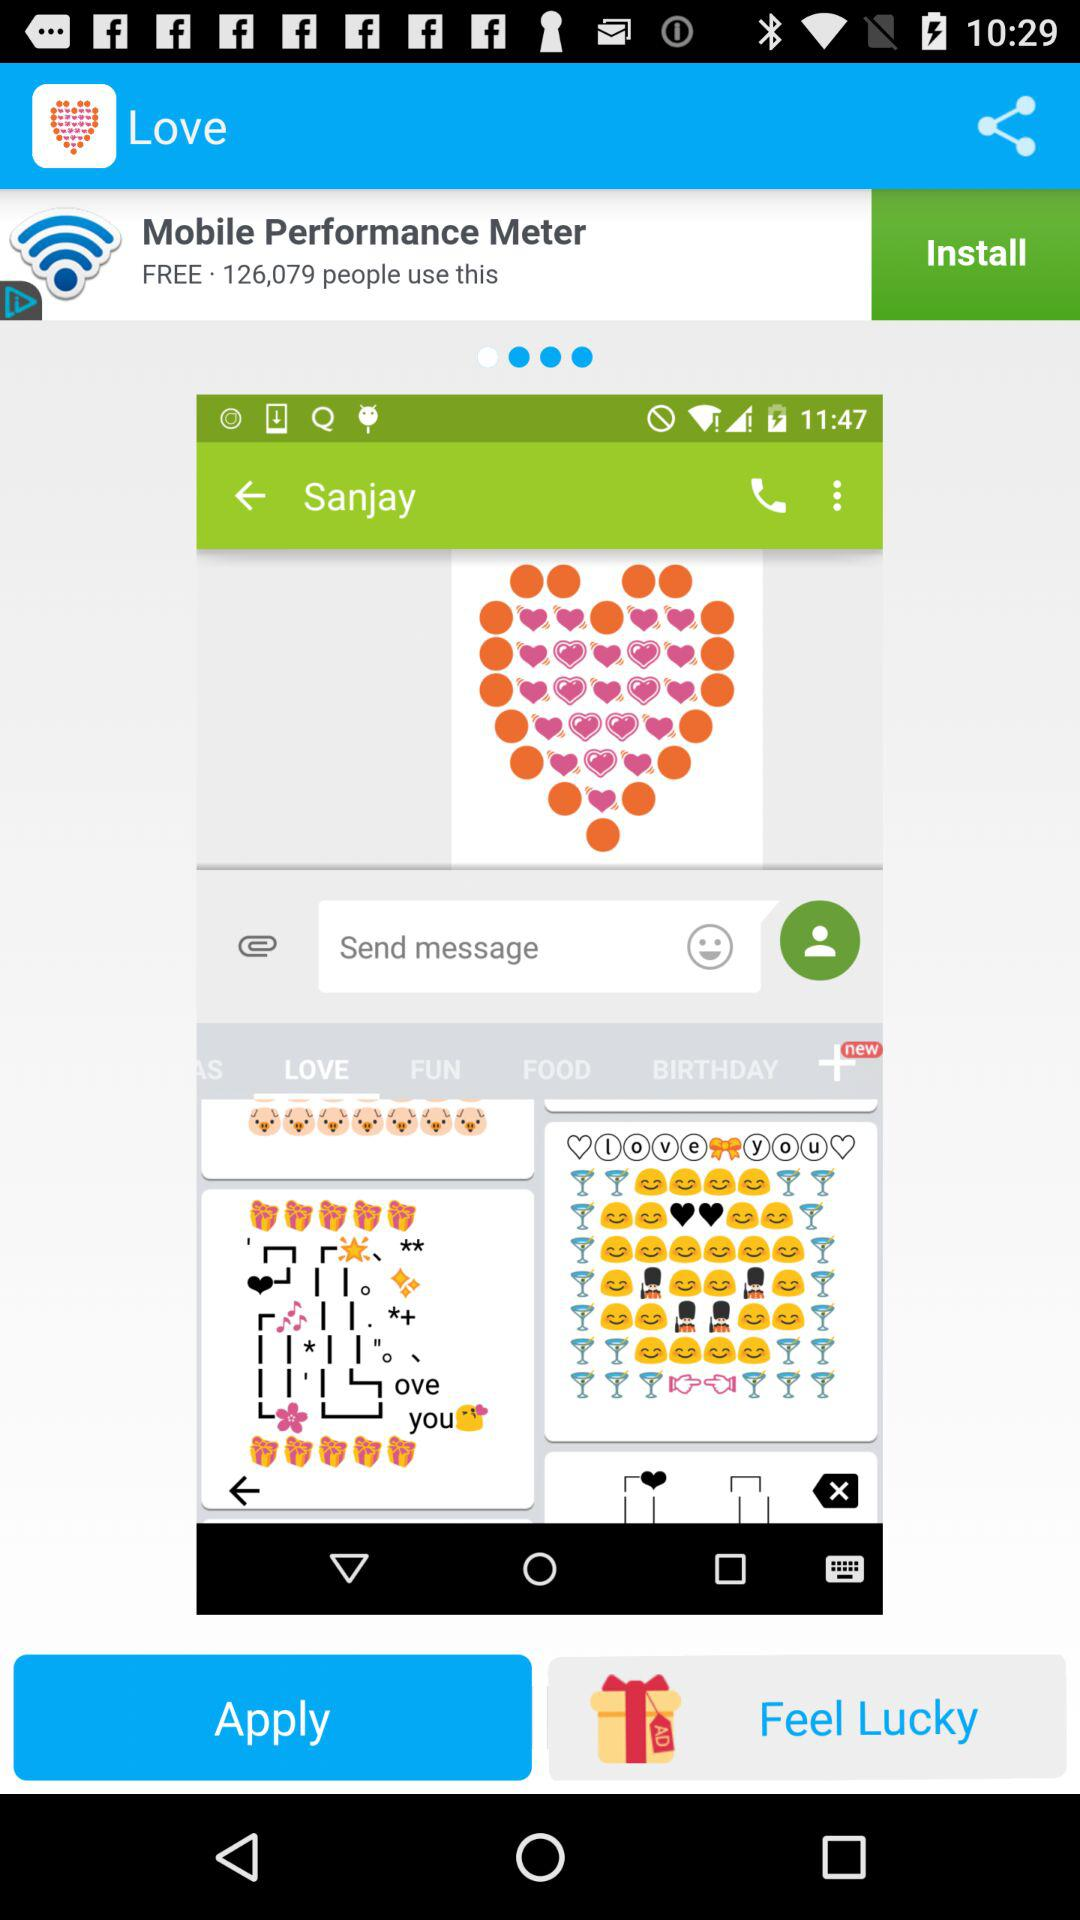How many people have used "Mobile Performance Meter"? It has been used by 126,079 people. 